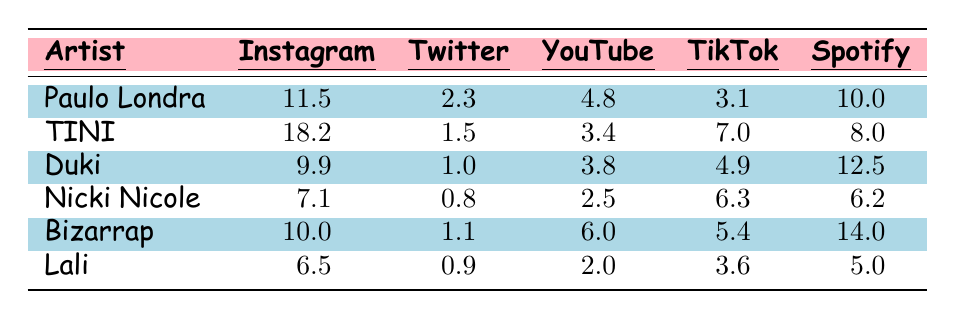What's the most followed artist on Instagram? The table shows the number of Instagram followers for each artist. By looking at the Instagram column, TINI has the highest number at 18.2 million followers.
Answer: TINI How many Twitter followers does Paulo Londra have? The table lists Paulo Londra's Twitter followers as 2.3 million.
Answer: 2.3 million Which artist has the lowest number of Spotify monthly listeners? By examining the Spotify column, Lali has the lowest number of monthly listeners at 5.0 million.
Answer: Lali What's the total number of Instagram followers for all artists combined? Adding the Instagram followers: 11.5 + 18.2 + 9.9 + 7.1 + 10.0 + 6.5 = 63.2 million.
Answer: 63.2 million Who has more YouTube subscribers, Duki or Nicki Nicole? Duki has 3.8 million YouTube subscribers while Nicki Nicole has 2.5 million. Since 3.8 is greater than 2.5, Duki has more subscribers.
Answer: Duki What is the average number of TikTok followers for the artists? The total TikTok followers are 3.1 + 7.0 + 4.9 + 6.3 + 5.4 + 3.6 = 30.3 million. There are 6 artists, so the average is 30.3 / 6 = 5.05 million.
Answer: 5.05 million Is it true that Bizarrap has more Spotify monthly listeners than TINI? Bizarrap has 14.0 million monthly listeners, and TINI has 8.0 million. Since 14.0 is greater than 8.0, this statement is true.
Answer: Yes Which artist has the highest number of YouTube subscribers, and what is that number? The highest YouTube subscribers belong to Bizarrap with 6.0 million subscribers.
Answer: Bizarrap, 6.0 million What is the difference in TikTok followers between Paulo Londra and Duki? Paulo Londra has 3.1 million TikTok followers and Duki has 4.9 million. The difference is 4.9 - 3.1 = 1.8 million.
Answer: 1.8 million Which artist has more Twitter followers, Nicki Nicole or Lali? Nicki Nicole has 0.8 million Twitter followers, and Lali has 0.9 million. Since 0.9 is greater than 0.8, Lali has more followers.
Answer: Lali 